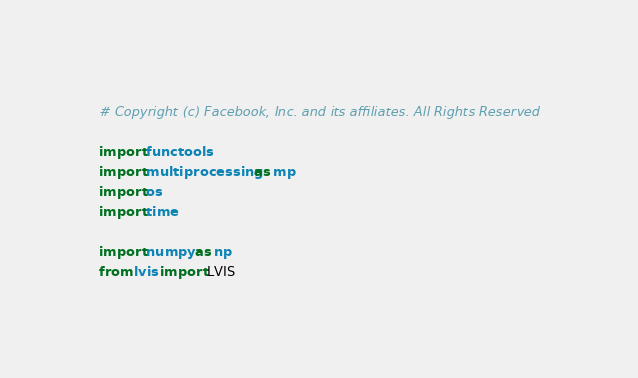Convert code to text. <code><loc_0><loc_0><loc_500><loc_500><_Python_># Copyright (c) Facebook, Inc. and its affiliates. All Rights Reserved

import functools
import multiprocessing as mp
import os
import time

import numpy as np
from lvis import LVIS</code> 